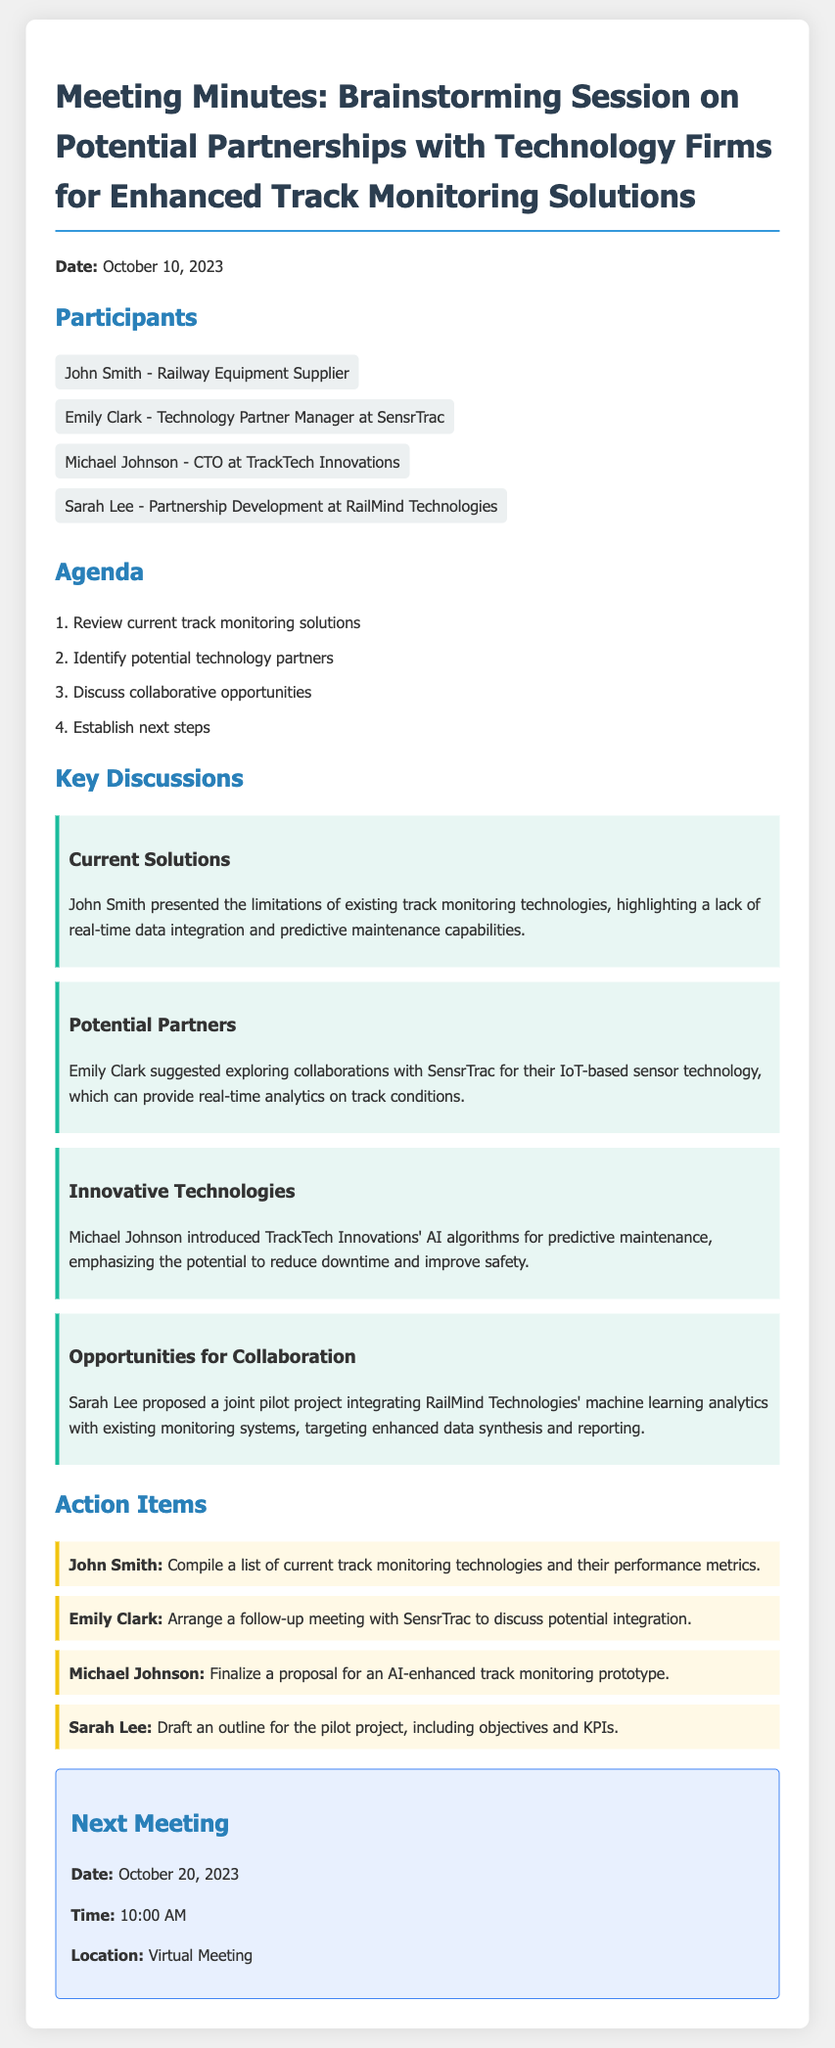What is the date of the meeting? The date of the meeting is specifically mentioned in the document.
Answer: October 10, 2023 Who is the participant from SensrTrac? The document identifies participants and their affiliations.
Answer: Emily Clark What technology did SensrTrac offer? The document details specific technologies proposed during the meeting.
Answer: IoT-based sensor technology What is one of the objectives for Sarah Lee's action item? The action items specify the tasks assigned to each participant, including objectives.
Answer: Draft an outline for the pilot project When is the next meeting scheduled? The document includes information about the next meeting date and time.
Answer: October 20, 2023 Which company introduced AI algorithms for predictive maintenance? The document highlights contributions from specific participants about their companies' technologies.
Answer: TrackTech Innovations What was a key limitation of current track monitoring technologies? The meeting minutes outline existing problems with current technologies discussed.
Answer: Lack of real-time data integration What was proposed as a joint project? The specific collaborative opportunity mentioned in the document can be summarized in a few words.
Answer: Pilot project integrating machine learning analytics 